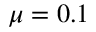Convert formula to latex. <formula><loc_0><loc_0><loc_500><loc_500>\mu = 0 . 1</formula> 